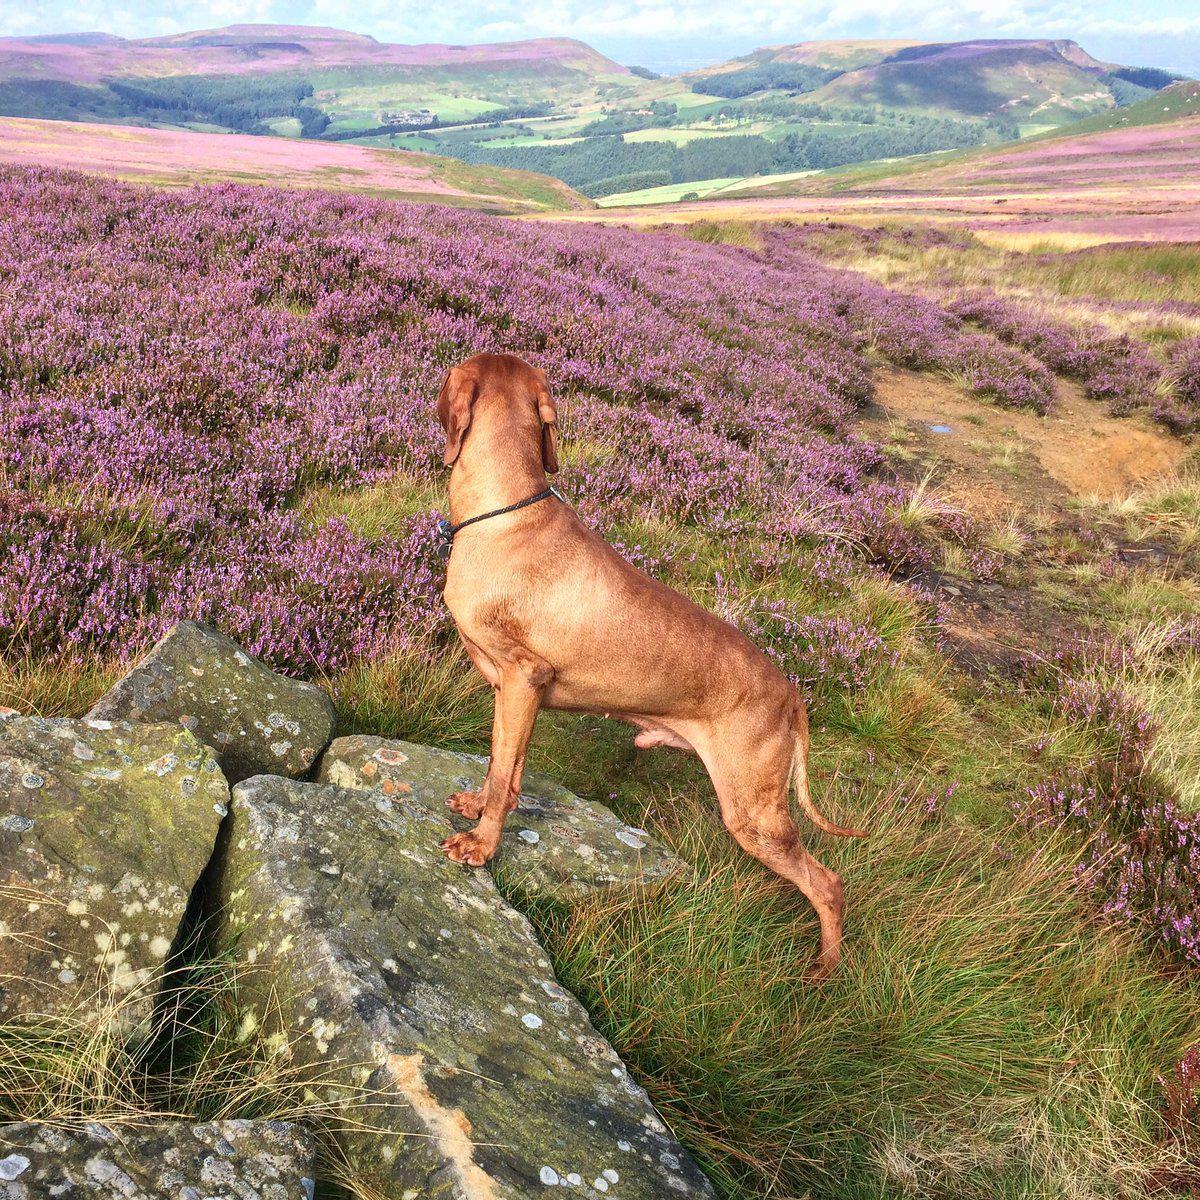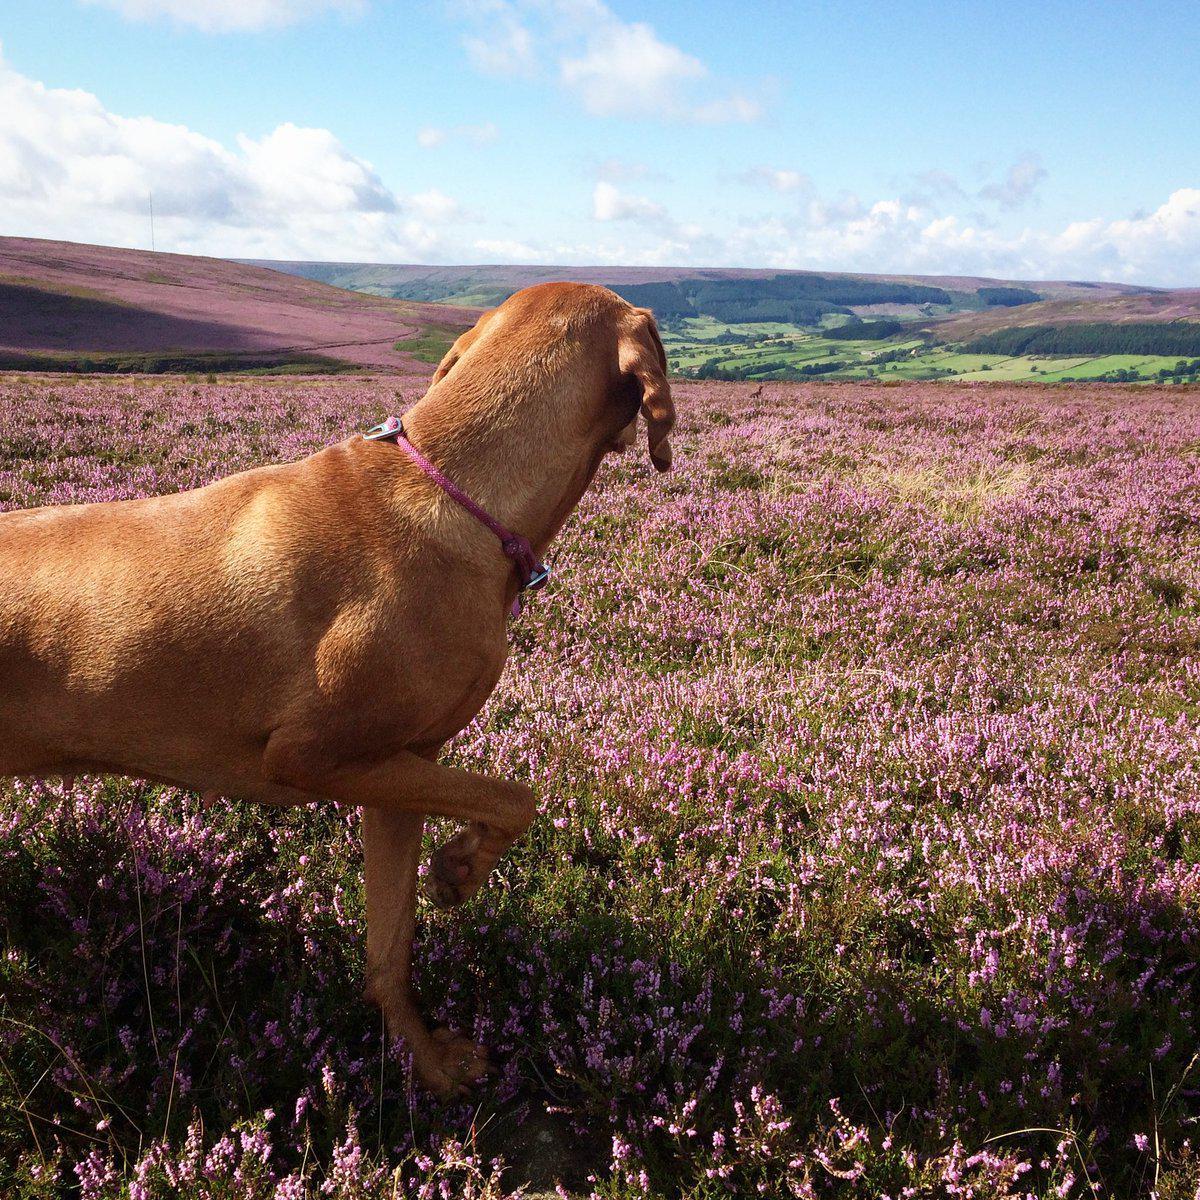The first image is the image on the left, the second image is the image on the right. Considering the images on both sides, is "In one image, a tan dog is standing upright with its front feet on a raised area before it, the back of its head visible as it looks away." valid? Answer yes or no. Yes. The first image is the image on the left, the second image is the image on the right. For the images shown, is this caption "The left image shows a dog with its front paws propped up, gazing toward a scenic view away from the camera, and the right image features purple flowers behind one dog." true? Answer yes or no. Yes. 